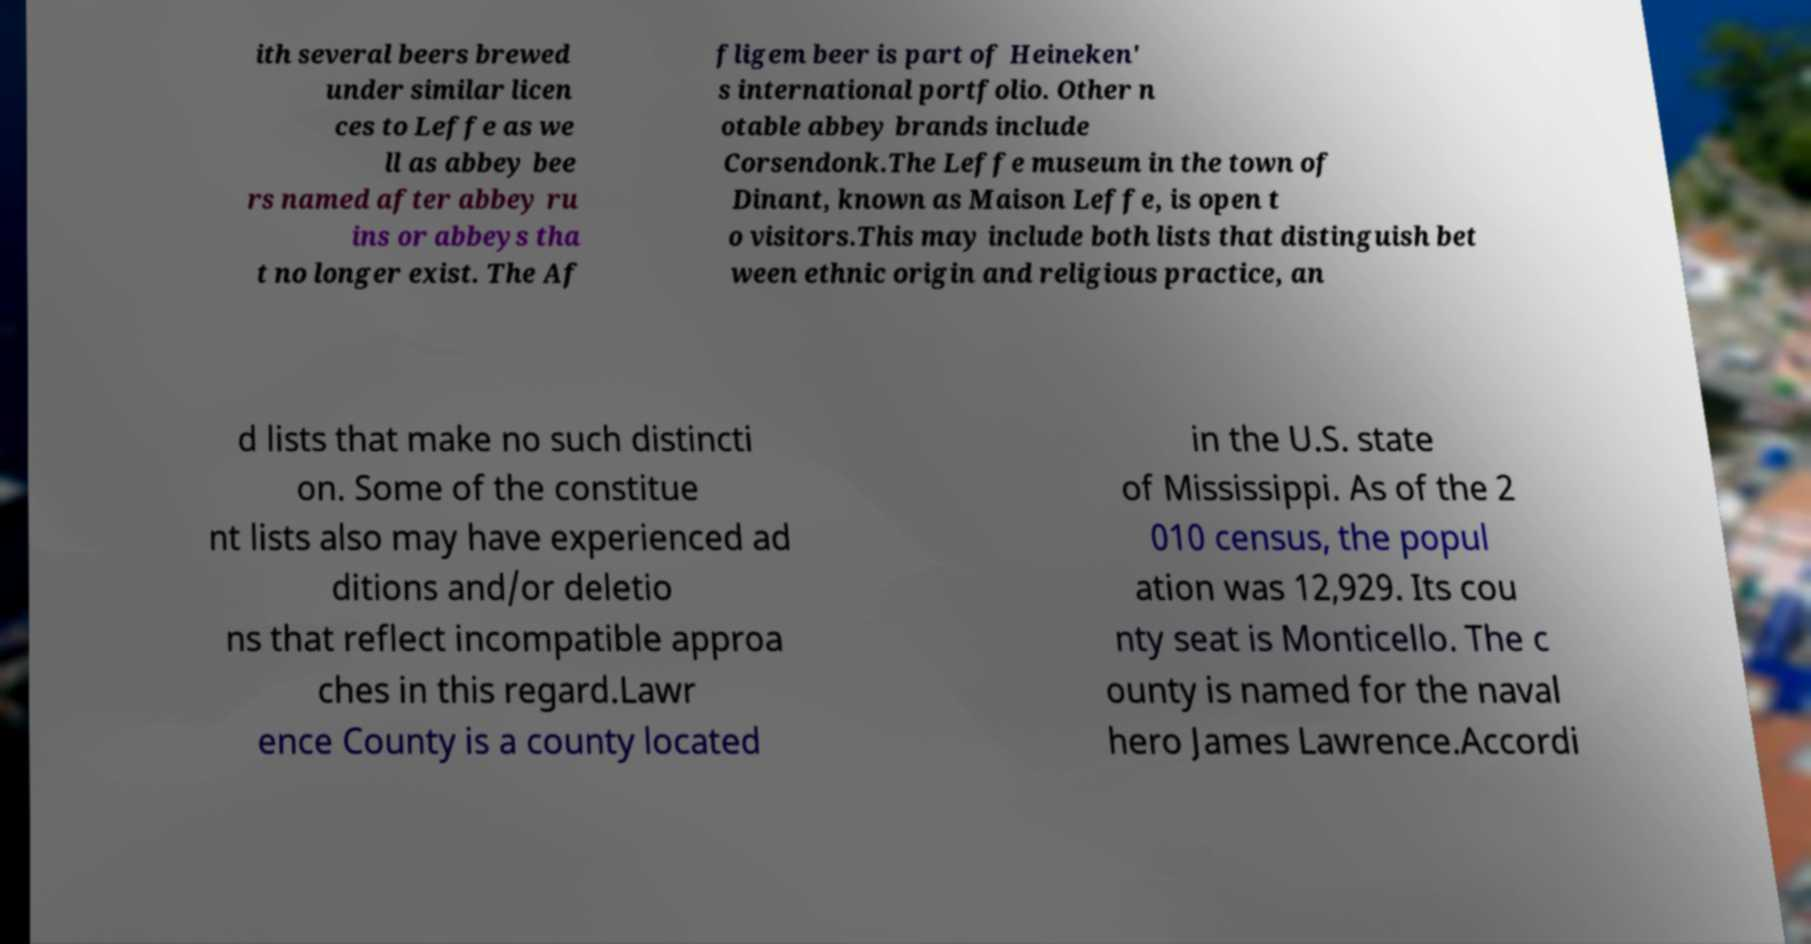Please identify and transcribe the text found in this image. ith several beers brewed under similar licen ces to Leffe as we ll as abbey bee rs named after abbey ru ins or abbeys tha t no longer exist. The Af fligem beer is part of Heineken' s international portfolio. Other n otable abbey brands include Corsendonk.The Leffe museum in the town of Dinant, known as Maison Leffe, is open t o visitors.This may include both lists that distinguish bet ween ethnic origin and religious practice, an d lists that make no such distincti on. Some of the constitue nt lists also may have experienced ad ditions and/or deletio ns that reflect incompatible approa ches in this regard.Lawr ence County is a county located in the U.S. state of Mississippi. As of the 2 010 census, the popul ation was 12,929. Its cou nty seat is Monticello. The c ounty is named for the naval hero James Lawrence.Accordi 